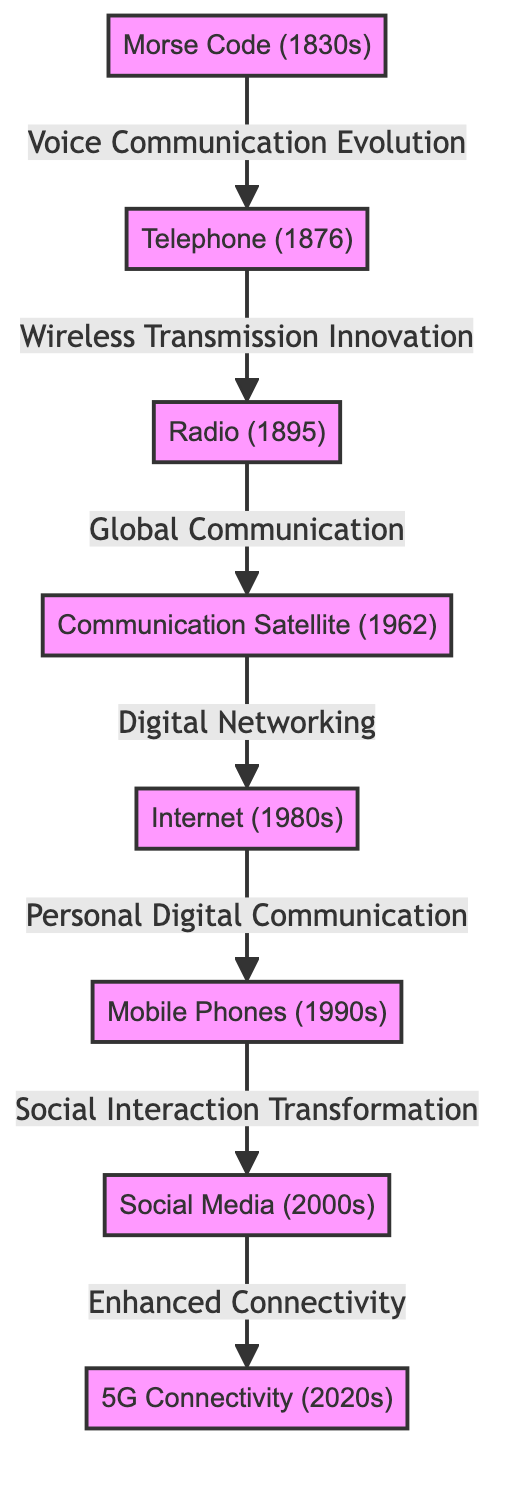What is the first node in the diagram? The first node in the diagram is "Morse Code (1830s)", which is the starting point for the evolution of telecommunications depicted in this flowchart.
Answer: Morse Code (1830s) How many nodes are present in the diagram? By counting each distinct node listed in the diagram, we find that there are a total of eight nodes that represent various milestones in telecommunications.
Answer: 8 What is the relationship between 'Radio' and 'Communication Satellite'? The relationship is defined by the phrase "Global Communication," indicating that radio technology enabled global communication, which later evolved into satellite communication.
Answer: Global Communication Which node directly connects to 'Mobile Phones'? The node that directly connects to 'Mobile Phones' is 'Internet', as indicated by the flow arrow leading from 'Internet' to 'Mobile Phones', showing the progression in communication technology.
Answer: Internet What is the significance of 'Social Media' in the progression of telecommunications? The significance of 'Social Media' is depicted by the phrase "Social Interaction Transformation," indicating its role in transforming how individuals interact and communicate using mobile technology.
Answer: Social Interaction Transformation What technological milestone came after 'Satellite'? Following 'Satellite', the next milestone in the diagram is 'Internet', signifying the evolution of telecommunications into digital networking and online communication.
Answer: Internet How does '5G Connectivity' relate to 'Social Media'? The relationship is characterized by the phrase "Enhanced Connectivity," which suggests that 5G technology enhances the effectiveness and reach of social media interactions.
Answer: Enhanced Connectivity Which historical telecommunications innovation occurred in the year 1876? The historical telecommunications innovation that occurred in 1876 is the invention of the 'Telephone', which marked a significant advancement in voice communication technology.
Answer: Telephone What is depicted as the last milestone in the telecommunications evolution? The last milestone depicted in the evolution process is '5G Connectivity (2020s)', representing the most advanced level of connectivity in telecommunications as illustrated in the diagram.
Answer: 5G Connectivity (2020s) 